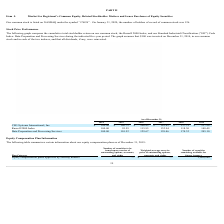According to Csg Systems International's financial document, How many common stock shareholders does the company have on January 31, 2020? According to the financial document, 126. The relevant text states: "e number of holders of record of common stock was 126...." Also, What symbol is the company's common stock listed under on NASDAQ? According to the financial document, CSGS. The relevant text states: "mmon stock is listed on NASDAQ under the symbol ‘‘CSGS’’. On January 31, 2020, the number of holders of record of common stock was 126...." Additionally, As of December 2019, which is the best performing stock? Data Preparation and Processing Services. The document states: "Data Preparation and Processing Services 100.00 110.52 129.67 159.46 174.32 245.10..." Additionally, Which stock enjoyed year on year growth between 2014 to 2019? Data Preparation and Processing Services. The document states: "Data Preparation and Processing Services 100.00 110.52 129.67 159.46 174.32 245.10..." Additionally, Between CSG Systems International, Inc and Russell 2000 Index, which performed better in the year 2015? CSG Systems International, Inc. The document states: "CSG Systems International, Inc. $ 100.00 $ 146.72 $ 200.85 $ 185.42 $ 137.31 $ 227.96..." Also, What is the cumulative total stockholder return of Russell 2000 Index as of 31 December, 2018? According to the financial document, 118.30. The relevant text states: "Russell 2000 Index 100.00 95.59 115.95 132.94 118.30 148.49..." 